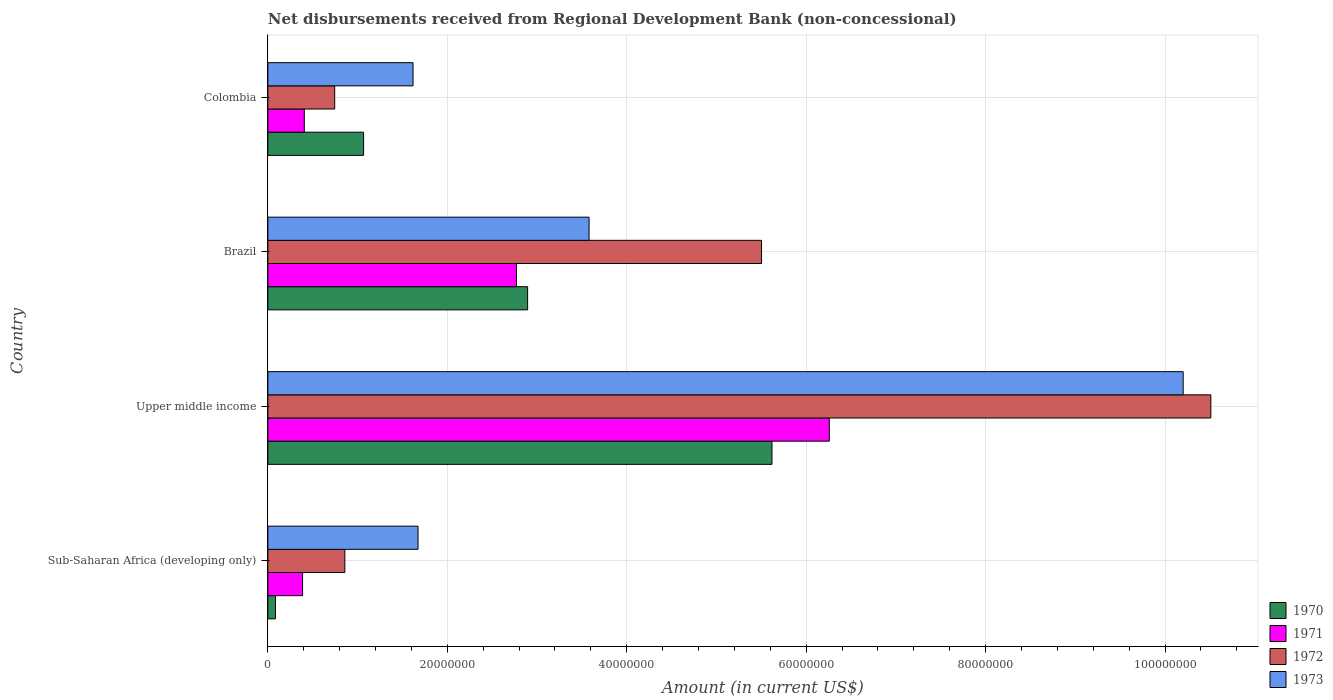How many bars are there on the 3rd tick from the bottom?
Keep it short and to the point. 4. What is the amount of disbursements received from Regional Development Bank in 1973 in Colombia?
Offer a very short reply. 1.62e+07. Across all countries, what is the maximum amount of disbursements received from Regional Development Bank in 1973?
Your answer should be very brief. 1.02e+08. Across all countries, what is the minimum amount of disbursements received from Regional Development Bank in 1971?
Offer a very short reply. 3.87e+06. In which country was the amount of disbursements received from Regional Development Bank in 1970 maximum?
Keep it short and to the point. Upper middle income. In which country was the amount of disbursements received from Regional Development Bank in 1970 minimum?
Your response must be concise. Sub-Saharan Africa (developing only). What is the total amount of disbursements received from Regional Development Bank in 1973 in the graph?
Ensure brevity in your answer.  1.71e+08. What is the difference between the amount of disbursements received from Regional Development Bank in 1973 in Colombia and that in Upper middle income?
Offer a terse response. -8.58e+07. What is the difference between the amount of disbursements received from Regional Development Bank in 1970 in Colombia and the amount of disbursements received from Regional Development Bank in 1973 in Upper middle income?
Make the answer very short. -9.13e+07. What is the average amount of disbursements received from Regional Development Bank in 1971 per country?
Provide a short and direct response. 2.46e+07. What is the difference between the amount of disbursements received from Regional Development Bank in 1973 and amount of disbursements received from Regional Development Bank in 1971 in Colombia?
Keep it short and to the point. 1.21e+07. What is the ratio of the amount of disbursements received from Regional Development Bank in 1972 in Brazil to that in Upper middle income?
Keep it short and to the point. 0.52. Is the amount of disbursements received from Regional Development Bank in 1973 in Colombia less than that in Sub-Saharan Africa (developing only)?
Your answer should be compact. Yes. What is the difference between the highest and the second highest amount of disbursements received from Regional Development Bank in 1971?
Keep it short and to the point. 3.49e+07. What is the difference between the highest and the lowest amount of disbursements received from Regional Development Bank in 1972?
Provide a short and direct response. 9.76e+07. In how many countries, is the amount of disbursements received from Regional Development Bank in 1972 greater than the average amount of disbursements received from Regional Development Bank in 1972 taken over all countries?
Your answer should be very brief. 2. Is the sum of the amount of disbursements received from Regional Development Bank in 1973 in Colombia and Sub-Saharan Africa (developing only) greater than the maximum amount of disbursements received from Regional Development Bank in 1970 across all countries?
Ensure brevity in your answer.  No. Is it the case that in every country, the sum of the amount of disbursements received from Regional Development Bank in 1970 and amount of disbursements received from Regional Development Bank in 1973 is greater than the sum of amount of disbursements received from Regional Development Bank in 1971 and amount of disbursements received from Regional Development Bank in 1972?
Provide a short and direct response. No. What does the 2nd bar from the top in Brazil represents?
Offer a very short reply. 1972. Are all the bars in the graph horizontal?
Provide a succinct answer. Yes. How many countries are there in the graph?
Offer a very short reply. 4. What is the difference between two consecutive major ticks on the X-axis?
Your answer should be very brief. 2.00e+07. Are the values on the major ticks of X-axis written in scientific E-notation?
Make the answer very short. No. Where does the legend appear in the graph?
Keep it short and to the point. Bottom right. How many legend labels are there?
Ensure brevity in your answer.  4. What is the title of the graph?
Offer a very short reply. Net disbursements received from Regional Development Bank (non-concessional). What is the label or title of the X-axis?
Ensure brevity in your answer.  Amount (in current US$). What is the Amount (in current US$) in 1970 in Sub-Saharan Africa (developing only)?
Provide a succinct answer. 8.50e+05. What is the Amount (in current US$) of 1971 in Sub-Saharan Africa (developing only)?
Your answer should be very brief. 3.87e+06. What is the Amount (in current US$) of 1972 in Sub-Saharan Africa (developing only)?
Ensure brevity in your answer.  8.58e+06. What is the Amount (in current US$) in 1973 in Sub-Saharan Africa (developing only)?
Ensure brevity in your answer.  1.67e+07. What is the Amount (in current US$) of 1970 in Upper middle income?
Offer a very short reply. 5.62e+07. What is the Amount (in current US$) in 1971 in Upper middle income?
Offer a very short reply. 6.26e+07. What is the Amount (in current US$) in 1972 in Upper middle income?
Provide a short and direct response. 1.05e+08. What is the Amount (in current US$) of 1973 in Upper middle income?
Your answer should be compact. 1.02e+08. What is the Amount (in current US$) in 1970 in Brazil?
Your answer should be compact. 2.90e+07. What is the Amount (in current US$) in 1971 in Brazil?
Keep it short and to the point. 2.77e+07. What is the Amount (in current US$) of 1972 in Brazil?
Offer a terse response. 5.50e+07. What is the Amount (in current US$) of 1973 in Brazil?
Ensure brevity in your answer.  3.58e+07. What is the Amount (in current US$) of 1970 in Colombia?
Keep it short and to the point. 1.07e+07. What is the Amount (in current US$) of 1971 in Colombia?
Offer a terse response. 4.06e+06. What is the Amount (in current US$) in 1972 in Colombia?
Your answer should be very brief. 7.45e+06. What is the Amount (in current US$) of 1973 in Colombia?
Ensure brevity in your answer.  1.62e+07. Across all countries, what is the maximum Amount (in current US$) of 1970?
Your answer should be compact. 5.62e+07. Across all countries, what is the maximum Amount (in current US$) of 1971?
Give a very brief answer. 6.26e+07. Across all countries, what is the maximum Amount (in current US$) in 1972?
Your answer should be very brief. 1.05e+08. Across all countries, what is the maximum Amount (in current US$) of 1973?
Keep it short and to the point. 1.02e+08. Across all countries, what is the minimum Amount (in current US$) of 1970?
Offer a terse response. 8.50e+05. Across all countries, what is the minimum Amount (in current US$) of 1971?
Offer a very short reply. 3.87e+06. Across all countries, what is the minimum Amount (in current US$) in 1972?
Your response must be concise. 7.45e+06. Across all countries, what is the minimum Amount (in current US$) in 1973?
Keep it short and to the point. 1.62e+07. What is the total Amount (in current US$) in 1970 in the graph?
Provide a short and direct response. 9.67e+07. What is the total Amount (in current US$) of 1971 in the graph?
Provide a short and direct response. 9.82e+07. What is the total Amount (in current US$) in 1972 in the graph?
Make the answer very short. 1.76e+08. What is the total Amount (in current US$) of 1973 in the graph?
Ensure brevity in your answer.  1.71e+08. What is the difference between the Amount (in current US$) in 1970 in Sub-Saharan Africa (developing only) and that in Upper middle income?
Make the answer very short. -5.53e+07. What is the difference between the Amount (in current US$) of 1971 in Sub-Saharan Africa (developing only) and that in Upper middle income?
Your answer should be very brief. -5.87e+07. What is the difference between the Amount (in current US$) of 1972 in Sub-Saharan Africa (developing only) and that in Upper middle income?
Make the answer very short. -9.65e+07. What is the difference between the Amount (in current US$) in 1973 in Sub-Saharan Africa (developing only) and that in Upper middle income?
Give a very brief answer. -8.53e+07. What is the difference between the Amount (in current US$) in 1970 in Sub-Saharan Africa (developing only) and that in Brazil?
Your answer should be compact. -2.81e+07. What is the difference between the Amount (in current US$) of 1971 in Sub-Saharan Africa (developing only) and that in Brazil?
Offer a terse response. -2.38e+07. What is the difference between the Amount (in current US$) of 1972 in Sub-Saharan Africa (developing only) and that in Brazil?
Your answer should be compact. -4.64e+07. What is the difference between the Amount (in current US$) in 1973 in Sub-Saharan Africa (developing only) and that in Brazil?
Offer a very short reply. -1.91e+07. What is the difference between the Amount (in current US$) of 1970 in Sub-Saharan Africa (developing only) and that in Colombia?
Provide a succinct answer. -9.82e+06. What is the difference between the Amount (in current US$) in 1971 in Sub-Saharan Africa (developing only) and that in Colombia?
Your answer should be very brief. -1.93e+05. What is the difference between the Amount (in current US$) in 1972 in Sub-Saharan Africa (developing only) and that in Colombia?
Your response must be concise. 1.13e+06. What is the difference between the Amount (in current US$) of 1973 in Sub-Saharan Africa (developing only) and that in Colombia?
Your response must be concise. 5.57e+05. What is the difference between the Amount (in current US$) in 1970 in Upper middle income and that in Brazil?
Your answer should be very brief. 2.72e+07. What is the difference between the Amount (in current US$) of 1971 in Upper middle income and that in Brazil?
Your response must be concise. 3.49e+07. What is the difference between the Amount (in current US$) in 1972 in Upper middle income and that in Brazil?
Provide a short and direct response. 5.01e+07. What is the difference between the Amount (in current US$) of 1973 in Upper middle income and that in Brazil?
Your answer should be compact. 6.62e+07. What is the difference between the Amount (in current US$) of 1970 in Upper middle income and that in Colombia?
Ensure brevity in your answer.  4.55e+07. What is the difference between the Amount (in current US$) in 1971 in Upper middle income and that in Colombia?
Make the answer very short. 5.85e+07. What is the difference between the Amount (in current US$) in 1972 in Upper middle income and that in Colombia?
Provide a short and direct response. 9.76e+07. What is the difference between the Amount (in current US$) in 1973 in Upper middle income and that in Colombia?
Keep it short and to the point. 8.58e+07. What is the difference between the Amount (in current US$) in 1970 in Brazil and that in Colombia?
Your response must be concise. 1.83e+07. What is the difference between the Amount (in current US$) in 1971 in Brazil and that in Colombia?
Keep it short and to the point. 2.36e+07. What is the difference between the Amount (in current US$) in 1972 in Brazil and that in Colombia?
Keep it short and to the point. 4.76e+07. What is the difference between the Amount (in current US$) of 1973 in Brazil and that in Colombia?
Offer a terse response. 1.96e+07. What is the difference between the Amount (in current US$) in 1970 in Sub-Saharan Africa (developing only) and the Amount (in current US$) in 1971 in Upper middle income?
Your answer should be compact. -6.17e+07. What is the difference between the Amount (in current US$) of 1970 in Sub-Saharan Africa (developing only) and the Amount (in current US$) of 1972 in Upper middle income?
Your answer should be very brief. -1.04e+08. What is the difference between the Amount (in current US$) of 1970 in Sub-Saharan Africa (developing only) and the Amount (in current US$) of 1973 in Upper middle income?
Give a very brief answer. -1.01e+08. What is the difference between the Amount (in current US$) in 1971 in Sub-Saharan Africa (developing only) and the Amount (in current US$) in 1972 in Upper middle income?
Offer a very short reply. -1.01e+08. What is the difference between the Amount (in current US$) of 1971 in Sub-Saharan Africa (developing only) and the Amount (in current US$) of 1973 in Upper middle income?
Your answer should be very brief. -9.81e+07. What is the difference between the Amount (in current US$) in 1972 in Sub-Saharan Africa (developing only) and the Amount (in current US$) in 1973 in Upper middle income?
Your response must be concise. -9.34e+07. What is the difference between the Amount (in current US$) in 1970 in Sub-Saharan Africa (developing only) and the Amount (in current US$) in 1971 in Brazil?
Make the answer very short. -2.69e+07. What is the difference between the Amount (in current US$) in 1970 in Sub-Saharan Africa (developing only) and the Amount (in current US$) in 1972 in Brazil?
Offer a terse response. -5.42e+07. What is the difference between the Amount (in current US$) of 1970 in Sub-Saharan Africa (developing only) and the Amount (in current US$) of 1973 in Brazil?
Your answer should be very brief. -3.50e+07. What is the difference between the Amount (in current US$) of 1971 in Sub-Saharan Africa (developing only) and the Amount (in current US$) of 1972 in Brazil?
Give a very brief answer. -5.12e+07. What is the difference between the Amount (in current US$) in 1971 in Sub-Saharan Africa (developing only) and the Amount (in current US$) in 1973 in Brazil?
Ensure brevity in your answer.  -3.19e+07. What is the difference between the Amount (in current US$) of 1972 in Sub-Saharan Africa (developing only) and the Amount (in current US$) of 1973 in Brazil?
Your answer should be very brief. -2.72e+07. What is the difference between the Amount (in current US$) in 1970 in Sub-Saharan Africa (developing only) and the Amount (in current US$) in 1971 in Colombia?
Provide a short and direct response. -3.21e+06. What is the difference between the Amount (in current US$) of 1970 in Sub-Saharan Africa (developing only) and the Amount (in current US$) of 1972 in Colombia?
Give a very brief answer. -6.60e+06. What is the difference between the Amount (in current US$) in 1970 in Sub-Saharan Africa (developing only) and the Amount (in current US$) in 1973 in Colombia?
Ensure brevity in your answer.  -1.53e+07. What is the difference between the Amount (in current US$) of 1971 in Sub-Saharan Africa (developing only) and the Amount (in current US$) of 1972 in Colombia?
Provide a succinct answer. -3.58e+06. What is the difference between the Amount (in current US$) in 1971 in Sub-Saharan Africa (developing only) and the Amount (in current US$) in 1973 in Colombia?
Provide a succinct answer. -1.23e+07. What is the difference between the Amount (in current US$) of 1972 in Sub-Saharan Africa (developing only) and the Amount (in current US$) of 1973 in Colombia?
Your answer should be very brief. -7.60e+06. What is the difference between the Amount (in current US$) of 1970 in Upper middle income and the Amount (in current US$) of 1971 in Brazil?
Offer a terse response. 2.85e+07. What is the difference between the Amount (in current US$) in 1970 in Upper middle income and the Amount (in current US$) in 1972 in Brazil?
Your response must be concise. 1.16e+06. What is the difference between the Amount (in current US$) of 1970 in Upper middle income and the Amount (in current US$) of 1973 in Brazil?
Provide a short and direct response. 2.04e+07. What is the difference between the Amount (in current US$) in 1971 in Upper middle income and the Amount (in current US$) in 1972 in Brazil?
Make the answer very short. 7.55e+06. What is the difference between the Amount (in current US$) of 1971 in Upper middle income and the Amount (in current US$) of 1973 in Brazil?
Ensure brevity in your answer.  2.68e+07. What is the difference between the Amount (in current US$) in 1972 in Upper middle income and the Amount (in current US$) in 1973 in Brazil?
Provide a succinct answer. 6.93e+07. What is the difference between the Amount (in current US$) of 1970 in Upper middle income and the Amount (in current US$) of 1971 in Colombia?
Ensure brevity in your answer.  5.21e+07. What is the difference between the Amount (in current US$) of 1970 in Upper middle income and the Amount (in current US$) of 1972 in Colombia?
Provide a succinct answer. 4.87e+07. What is the difference between the Amount (in current US$) in 1970 in Upper middle income and the Amount (in current US$) in 1973 in Colombia?
Offer a very short reply. 4.00e+07. What is the difference between the Amount (in current US$) of 1971 in Upper middle income and the Amount (in current US$) of 1972 in Colombia?
Give a very brief answer. 5.51e+07. What is the difference between the Amount (in current US$) of 1971 in Upper middle income and the Amount (in current US$) of 1973 in Colombia?
Offer a very short reply. 4.64e+07. What is the difference between the Amount (in current US$) in 1972 in Upper middle income and the Amount (in current US$) in 1973 in Colombia?
Offer a terse response. 8.89e+07. What is the difference between the Amount (in current US$) in 1970 in Brazil and the Amount (in current US$) in 1971 in Colombia?
Provide a short and direct response. 2.49e+07. What is the difference between the Amount (in current US$) in 1970 in Brazil and the Amount (in current US$) in 1972 in Colombia?
Ensure brevity in your answer.  2.15e+07. What is the difference between the Amount (in current US$) in 1970 in Brazil and the Amount (in current US$) in 1973 in Colombia?
Your answer should be very brief. 1.28e+07. What is the difference between the Amount (in current US$) of 1971 in Brazil and the Amount (in current US$) of 1972 in Colombia?
Offer a very short reply. 2.03e+07. What is the difference between the Amount (in current US$) in 1971 in Brazil and the Amount (in current US$) in 1973 in Colombia?
Your response must be concise. 1.15e+07. What is the difference between the Amount (in current US$) in 1972 in Brazil and the Amount (in current US$) in 1973 in Colombia?
Your answer should be compact. 3.88e+07. What is the average Amount (in current US$) in 1970 per country?
Your answer should be compact. 2.42e+07. What is the average Amount (in current US$) of 1971 per country?
Provide a succinct answer. 2.46e+07. What is the average Amount (in current US$) of 1972 per country?
Your answer should be very brief. 4.40e+07. What is the average Amount (in current US$) in 1973 per country?
Make the answer very short. 4.27e+07. What is the difference between the Amount (in current US$) of 1970 and Amount (in current US$) of 1971 in Sub-Saharan Africa (developing only)?
Your answer should be compact. -3.02e+06. What is the difference between the Amount (in current US$) of 1970 and Amount (in current US$) of 1972 in Sub-Saharan Africa (developing only)?
Your answer should be compact. -7.73e+06. What is the difference between the Amount (in current US$) of 1970 and Amount (in current US$) of 1973 in Sub-Saharan Africa (developing only)?
Your answer should be very brief. -1.59e+07. What is the difference between the Amount (in current US$) in 1971 and Amount (in current US$) in 1972 in Sub-Saharan Africa (developing only)?
Your answer should be very brief. -4.71e+06. What is the difference between the Amount (in current US$) in 1971 and Amount (in current US$) in 1973 in Sub-Saharan Africa (developing only)?
Keep it short and to the point. -1.29e+07. What is the difference between the Amount (in current US$) in 1972 and Amount (in current US$) in 1973 in Sub-Saharan Africa (developing only)?
Ensure brevity in your answer.  -8.16e+06. What is the difference between the Amount (in current US$) of 1970 and Amount (in current US$) of 1971 in Upper middle income?
Ensure brevity in your answer.  -6.39e+06. What is the difference between the Amount (in current US$) in 1970 and Amount (in current US$) in 1972 in Upper middle income?
Your response must be concise. -4.89e+07. What is the difference between the Amount (in current US$) of 1970 and Amount (in current US$) of 1973 in Upper middle income?
Offer a terse response. -4.58e+07. What is the difference between the Amount (in current US$) in 1971 and Amount (in current US$) in 1972 in Upper middle income?
Your answer should be very brief. -4.25e+07. What is the difference between the Amount (in current US$) of 1971 and Amount (in current US$) of 1973 in Upper middle income?
Your answer should be very brief. -3.94e+07. What is the difference between the Amount (in current US$) in 1972 and Amount (in current US$) in 1973 in Upper middle income?
Make the answer very short. 3.08e+06. What is the difference between the Amount (in current US$) of 1970 and Amount (in current US$) of 1971 in Brazil?
Make the answer very short. 1.25e+06. What is the difference between the Amount (in current US$) in 1970 and Amount (in current US$) in 1972 in Brazil?
Provide a succinct answer. -2.61e+07. What is the difference between the Amount (in current US$) in 1970 and Amount (in current US$) in 1973 in Brazil?
Offer a very short reply. -6.85e+06. What is the difference between the Amount (in current US$) of 1971 and Amount (in current US$) of 1972 in Brazil?
Ensure brevity in your answer.  -2.73e+07. What is the difference between the Amount (in current US$) in 1971 and Amount (in current US$) in 1973 in Brazil?
Your response must be concise. -8.10e+06. What is the difference between the Amount (in current US$) in 1972 and Amount (in current US$) in 1973 in Brazil?
Your answer should be compact. 1.92e+07. What is the difference between the Amount (in current US$) in 1970 and Amount (in current US$) in 1971 in Colombia?
Offer a very short reply. 6.61e+06. What is the difference between the Amount (in current US$) in 1970 and Amount (in current US$) in 1972 in Colombia?
Provide a short and direct response. 3.22e+06. What is the difference between the Amount (in current US$) of 1970 and Amount (in current US$) of 1973 in Colombia?
Ensure brevity in your answer.  -5.51e+06. What is the difference between the Amount (in current US$) of 1971 and Amount (in current US$) of 1972 in Colombia?
Provide a short and direct response. -3.39e+06. What is the difference between the Amount (in current US$) in 1971 and Amount (in current US$) in 1973 in Colombia?
Offer a very short reply. -1.21e+07. What is the difference between the Amount (in current US$) of 1972 and Amount (in current US$) of 1973 in Colombia?
Your response must be concise. -8.73e+06. What is the ratio of the Amount (in current US$) in 1970 in Sub-Saharan Africa (developing only) to that in Upper middle income?
Provide a short and direct response. 0.02. What is the ratio of the Amount (in current US$) of 1971 in Sub-Saharan Africa (developing only) to that in Upper middle income?
Provide a succinct answer. 0.06. What is the ratio of the Amount (in current US$) of 1972 in Sub-Saharan Africa (developing only) to that in Upper middle income?
Give a very brief answer. 0.08. What is the ratio of the Amount (in current US$) of 1973 in Sub-Saharan Africa (developing only) to that in Upper middle income?
Offer a terse response. 0.16. What is the ratio of the Amount (in current US$) of 1970 in Sub-Saharan Africa (developing only) to that in Brazil?
Ensure brevity in your answer.  0.03. What is the ratio of the Amount (in current US$) in 1971 in Sub-Saharan Africa (developing only) to that in Brazil?
Ensure brevity in your answer.  0.14. What is the ratio of the Amount (in current US$) of 1972 in Sub-Saharan Africa (developing only) to that in Brazil?
Your answer should be compact. 0.16. What is the ratio of the Amount (in current US$) in 1973 in Sub-Saharan Africa (developing only) to that in Brazil?
Provide a succinct answer. 0.47. What is the ratio of the Amount (in current US$) of 1970 in Sub-Saharan Africa (developing only) to that in Colombia?
Make the answer very short. 0.08. What is the ratio of the Amount (in current US$) of 1971 in Sub-Saharan Africa (developing only) to that in Colombia?
Make the answer very short. 0.95. What is the ratio of the Amount (in current US$) of 1972 in Sub-Saharan Africa (developing only) to that in Colombia?
Your response must be concise. 1.15. What is the ratio of the Amount (in current US$) in 1973 in Sub-Saharan Africa (developing only) to that in Colombia?
Give a very brief answer. 1.03. What is the ratio of the Amount (in current US$) of 1970 in Upper middle income to that in Brazil?
Offer a very short reply. 1.94. What is the ratio of the Amount (in current US$) in 1971 in Upper middle income to that in Brazil?
Provide a short and direct response. 2.26. What is the ratio of the Amount (in current US$) of 1972 in Upper middle income to that in Brazil?
Keep it short and to the point. 1.91. What is the ratio of the Amount (in current US$) in 1973 in Upper middle income to that in Brazil?
Offer a very short reply. 2.85. What is the ratio of the Amount (in current US$) in 1970 in Upper middle income to that in Colombia?
Your answer should be very brief. 5.27. What is the ratio of the Amount (in current US$) in 1971 in Upper middle income to that in Colombia?
Offer a very short reply. 15.4. What is the ratio of the Amount (in current US$) of 1972 in Upper middle income to that in Colombia?
Your answer should be very brief. 14.11. What is the ratio of the Amount (in current US$) in 1973 in Upper middle income to that in Colombia?
Provide a short and direct response. 6.3. What is the ratio of the Amount (in current US$) of 1970 in Brazil to that in Colombia?
Give a very brief answer. 2.71. What is the ratio of the Amount (in current US$) of 1971 in Brazil to that in Colombia?
Give a very brief answer. 6.82. What is the ratio of the Amount (in current US$) of 1972 in Brazil to that in Colombia?
Keep it short and to the point. 7.39. What is the ratio of the Amount (in current US$) in 1973 in Brazil to that in Colombia?
Your response must be concise. 2.21. What is the difference between the highest and the second highest Amount (in current US$) in 1970?
Your answer should be very brief. 2.72e+07. What is the difference between the highest and the second highest Amount (in current US$) in 1971?
Make the answer very short. 3.49e+07. What is the difference between the highest and the second highest Amount (in current US$) of 1972?
Your response must be concise. 5.01e+07. What is the difference between the highest and the second highest Amount (in current US$) in 1973?
Your response must be concise. 6.62e+07. What is the difference between the highest and the lowest Amount (in current US$) of 1970?
Provide a succinct answer. 5.53e+07. What is the difference between the highest and the lowest Amount (in current US$) of 1971?
Your answer should be very brief. 5.87e+07. What is the difference between the highest and the lowest Amount (in current US$) of 1972?
Your answer should be very brief. 9.76e+07. What is the difference between the highest and the lowest Amount (in current US$) of 1973?
Ensure brevity in your answer.  8.58e+07. 